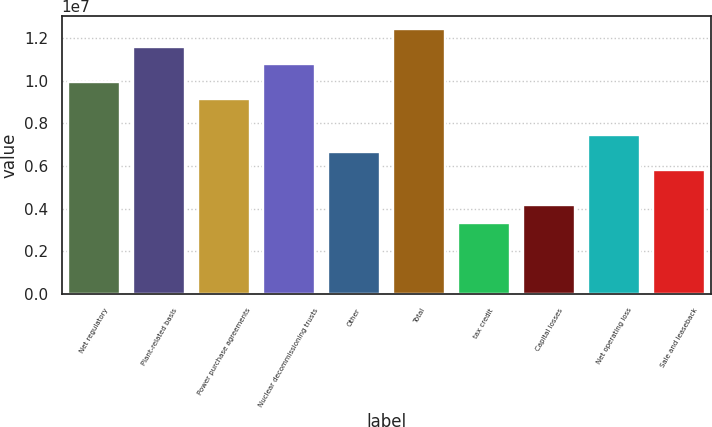<chart> <loc_0><loc_0><loc_500><loc_500><bar_chart><fcel>Net regulatory<fcel>Plant-related basis<fcel>Power purchase agreements<fcel>Nuclear decommissioning trusts<fcel>Other<fcel>Total<fcel>tax credit<fcel>Capital losses<fcel>Net operating loss<fcel>Sale and leaseback<nl><fcel>9.94999e+06<fcel>1.16037e+07<fcel>9.12314e+06<fcel>1.07768e+07<fcel>6.6426e+06<fcel>1.24305e+07<fcel>3.33522e+06<fcel>4.16207e+06<fcel>7.46945e+06<fcel>5.81576e+06<nl></chart> 